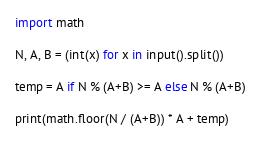<code> <loc_0><loc_0><loc_500><loc_500><_Python_>import math

N, A, B = (int(x) for x in input().split())

temp = A if N % (A+B) >= A else N % (A+B)

print(math.floor(N / (A+B)) * A + temp)</code> 